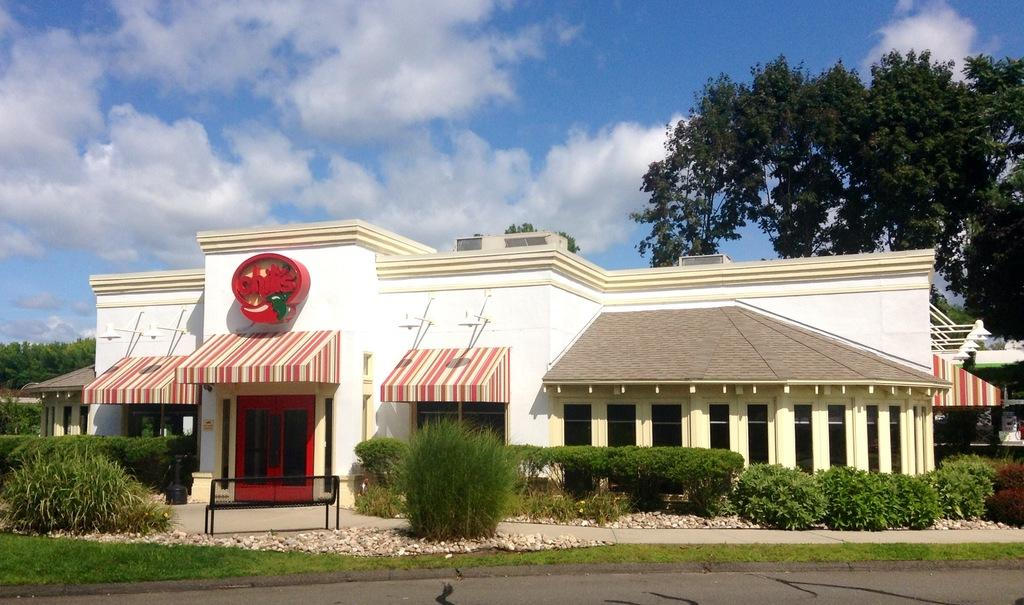<image>
Create a compact narrative representing the image presented. A Chili's restaurant has striped awnings and a red sign.. 